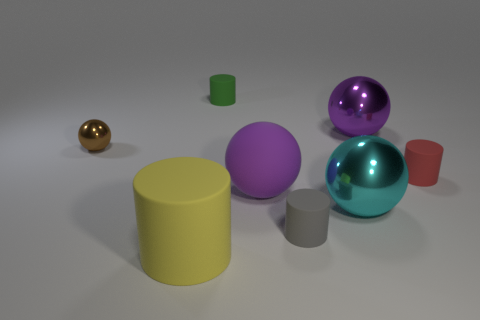There is a big purple sphere that is on the left side of the tiny gray thing; what is it made of? The big purple sphere in the image appears to be made of a smooth, reflective material, which could be either plastic or glass, common materials used in the creation of visually appealing 3D models. 